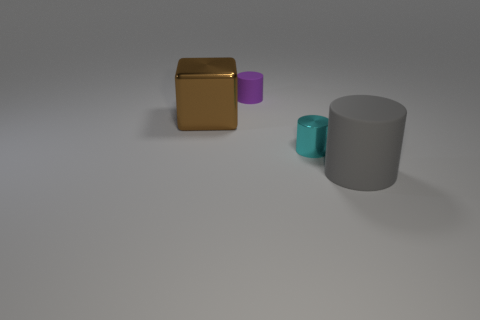Is there anything else that has the same shape as the large metal thing?
Ensure brevity in your answer.  No. What is the size of the gray matte object that is the same shape as the small purple matte thing?
Your answer should be very brief. Large. How many blue objects are either tiny metal cylinders or large metal cubes?
Provide a short and direct response. 0. There is a large thing that is on the right side of the small purple thing; what number of tiny matte cylinders are behind it?
Provide a succinct answer. 1. How many other objects are there of the same shape as the purple matte object?
Make the answer very short. 2. How many other objects are the same color as the small rubber thing?
Offer a terse response. 0. There is a thing that is the same material as the small cyan cylinder; what color is it?
Your response must be concise. Brown. Are there any gray cylinders that have the same size as the cyan object?
Provide a succinct answer. No. Are there more brown shiny things left of the small purple matte cylinder than big metal blocks on the right side of the large gray matte object?
Keep it short and to the point. Yes. Are the large object that is behind the big gray matte cylinder and the purple cylinder behind the gray rubber object made of the same material?
Provide a short and direct response. No. 